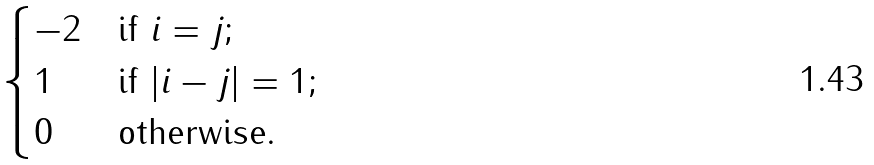<formula> <loc_0><loc_0><loc_500><loc_500>\begin{cases} - 2 & \text {if $i=j$;} \\ 1 & \text {if $|i-j|=1$;} \\ 0 & \text {otherwise.} \end{cases}</formula> 